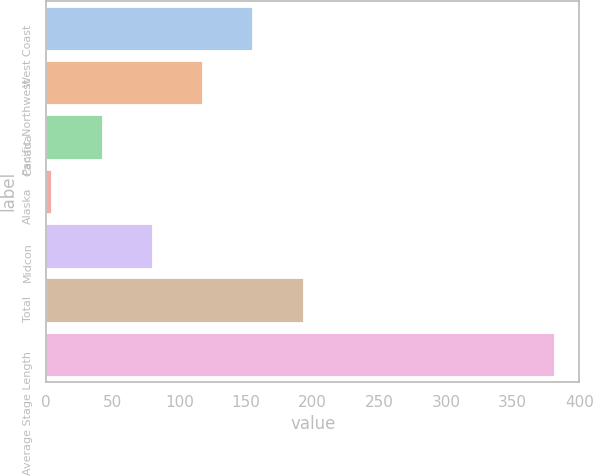Convert chart. <chart><loc_0><loc_0><loc_500><loc_500><bar_chart><fcel>West Coast<fcel>Pacific Northwest<fcel>Canada<fcel>Alaska<fcel>Midcon<fcel>Total<fcel>Average Stage Length<nl><fcel>154.8<fcel>117.1<fcel>41.7<fcel>4<fcel>79.4<fcel>192.5<fcel>381<nl></chart> 